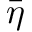Convert formula to latex. <formula><loc_0><loc_0><loc_500><loc_500>\bar { \eta }</formula> 